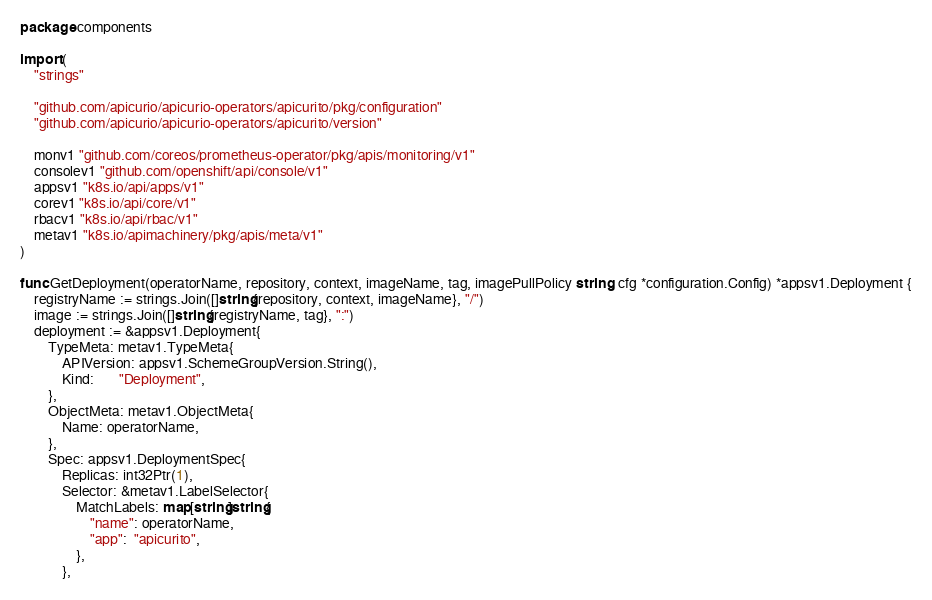<code> <loc_0><loc_0><loc_500><loc_500><_Go_>package components

import (
	"strings"

	"github.com/apicurio/apicurio-operators/apicurito/pkg/configuration"
	"github.com/apicurio/apicurio-operators/apicurito/version"

	monv1 "github.com/coreos/prometheus-operator/pkg/apis/monitoring/v1"
	consolev1 "github.com/openshift/api/console/v1"
	appsv1 "k8s.io/api/apps/v1"
	corev1 "k8s.io/api/core/v1"
	rbacv1 "k8s.io/api/rbac/v1"
	metav1 "k8s.io/apimachinery/pkg/apis/meta/v1"
)

func GetDeployment(operatorName, repository, context, imageName, tag, imagePullPolicy string, cfg *configuration.Config) *appsv1.Deployment {
	registryName := strings.Join([]string{repository, context, imageName}, "/")
	image := strings.Join([]string{registryName, tag}, ":")
	deployment := &appsv1.Deployment{
		TypeMeta: metav1.TypeMeta{
			APIVersion: appsv1.SchemeGroupVersion.String(),
			Kind:       "Deployment",
		},
		ObjectMeta: metav1.ObjectMeta{
			Name: operatorName,
		},
		Spec: appsv1.DeploymentSpec{
			Replicas: int32Ptr(1),
			Selector: &metav1.LabelSelector{
				MatchLabels: map[string]string{
					"name": operatorName,
					"app":  "apicurito",
				},
			},</code> 